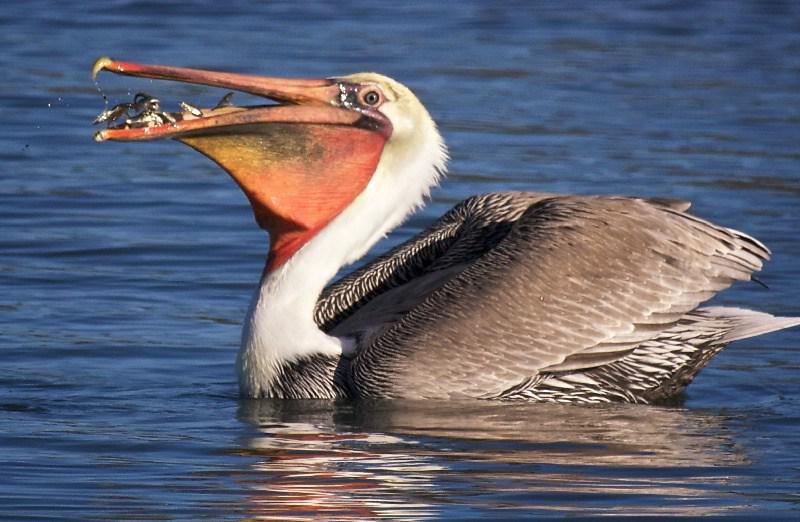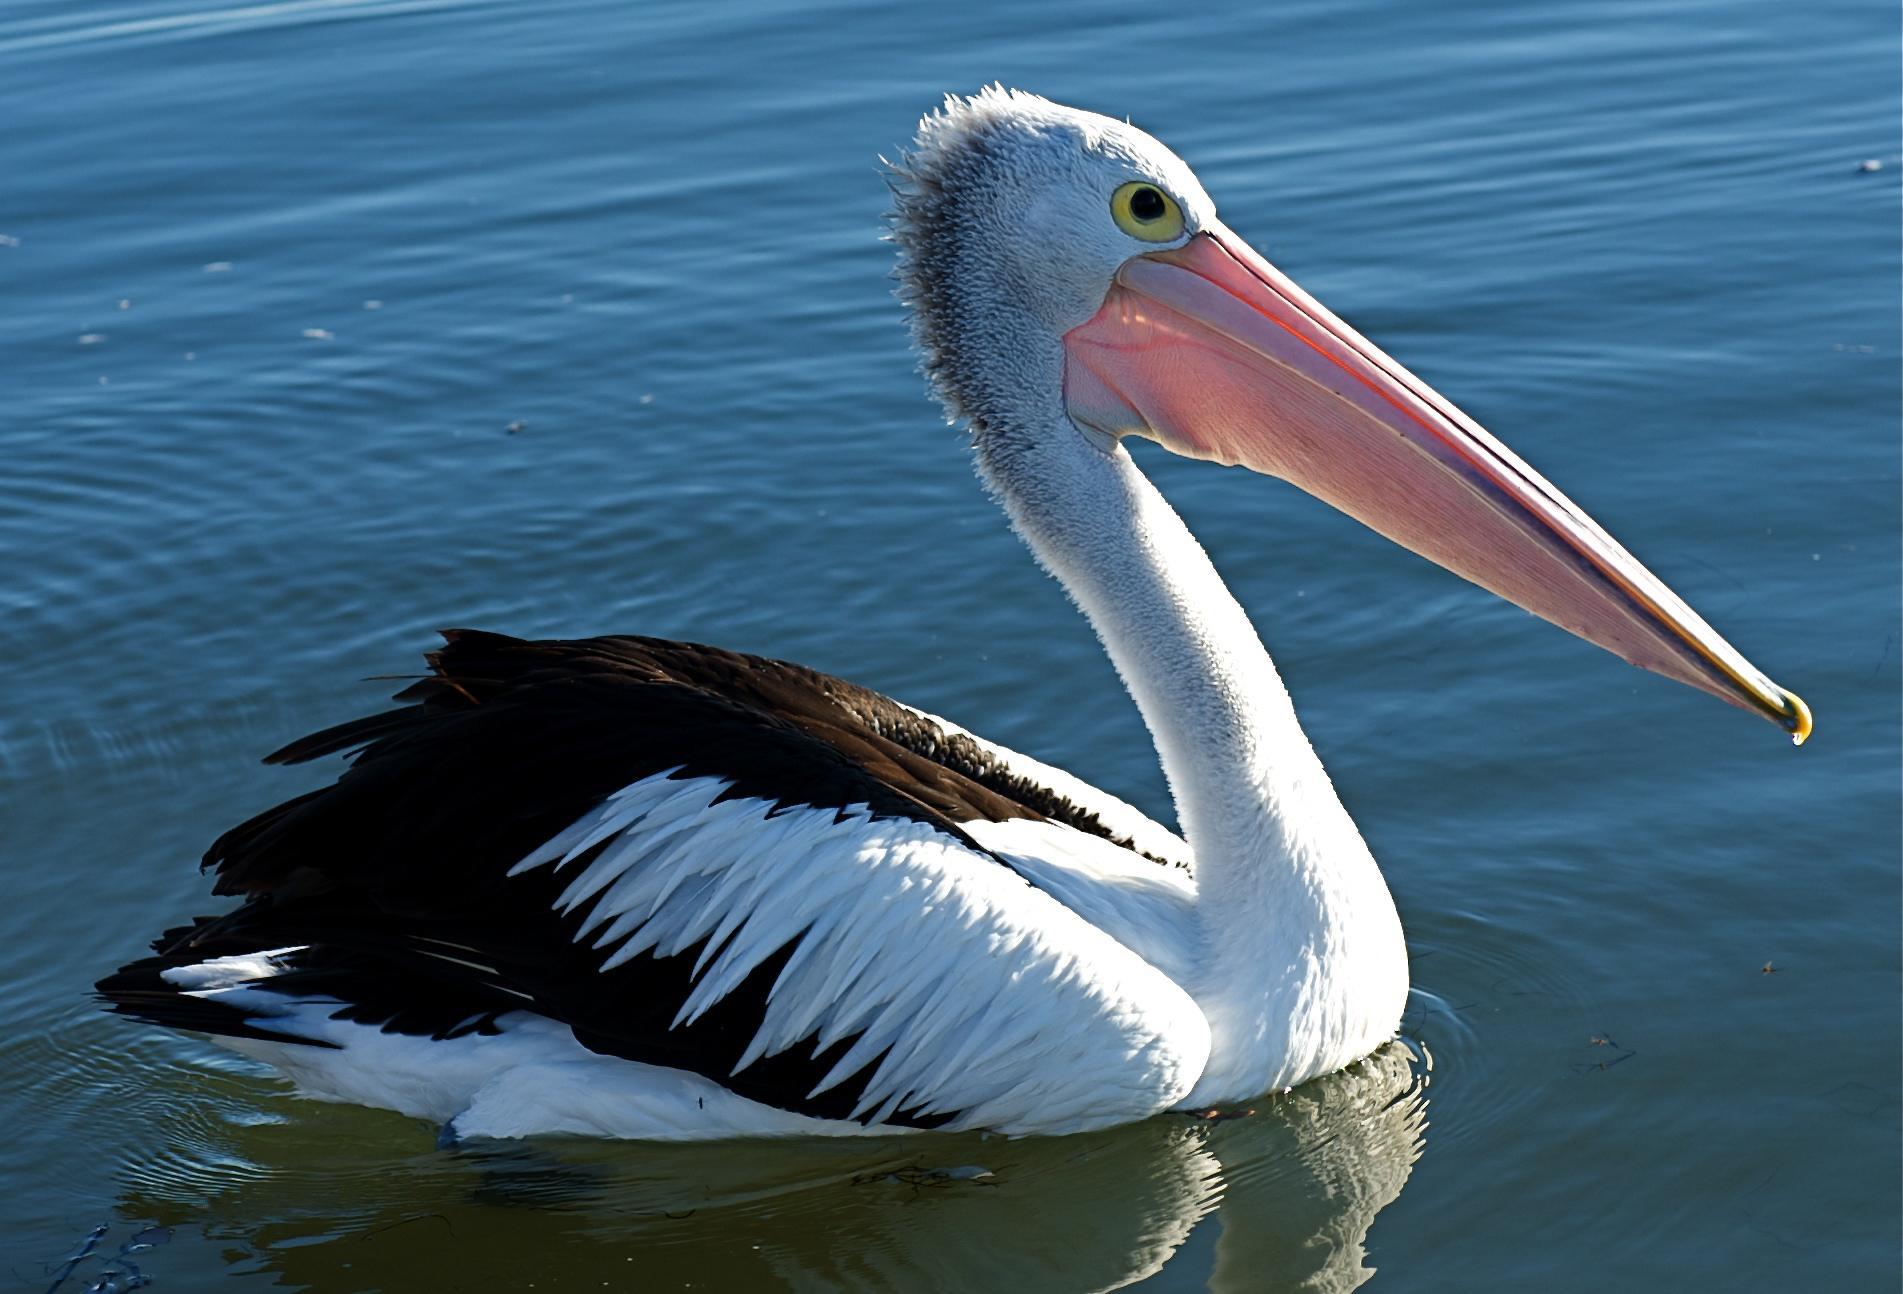The first image is the image on the left, the second image is the image on the right. Considering the images on both sides, is "One image shows exactly one pelican on water facing right, and the other image shows a pelican flying above water." valid? Answer yes or no. No. The first image is the image on the left, the second image is the image on the right. Evaluate the accuracy of this statement regarding the images: "there is a single pelican in flight with the wings in the downward position". Is it true? Answer yes or no. No. 